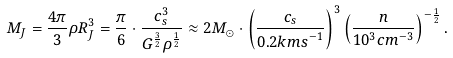Convert formula to latex. <formula><loc_0><loc_0><loc_500><loc_500>M _ { J } = { \frac { 4 \pi } { 3 } } \rho R _ { J } ^ { 3 } = { \frac { \pi } { 6 } } \cdot { \frac { c _ { s } ^ { 3 } } { G ^ { \frac { 3 } { 2 } } \rho ^ { \frac { 1 } { 2 } } } } \approx 2 { M } _ { \odot } \cdot \left ( { \frac { c _ { s } } { 0 . 2 { k m s } ^ { - 1 } } } \right ) ^ { 3 } \left ( { \frac { n } { 1 0 ^ { 3 } { c m } ^ { - 3 } } } \right ) ^ { - { \frac { 1 } { 2 } } } .</formula> 